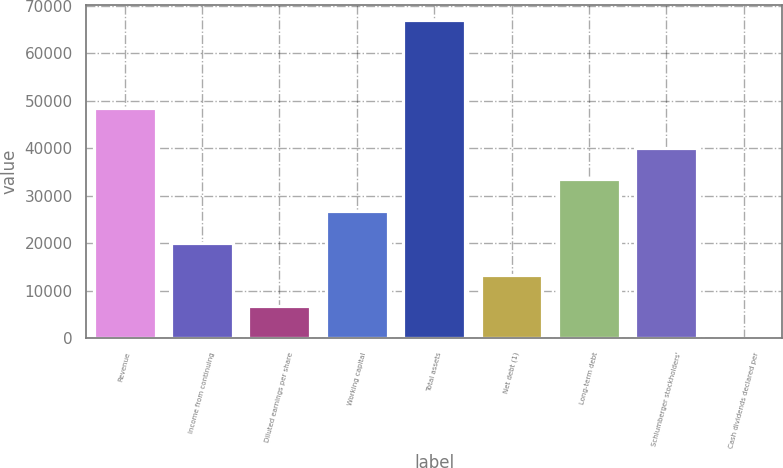Convert chart. <chart><loc_0><loc_0><loc_500><loc_500><bar_chart><fcel>Revenue<fcel>Income from continuing<fcel>Diluted earnings per share<fcel>Working capital<fcel>Total assets<fcel>Net debt (1)<fcel>Long-term debt<fcel>Schlumberger stockholders'<fcel>Cash dividends declared per<nl><fcel>48580<fcel>20072.3<fcel>6691.84<fcel>26762.6<fcel>66904<fcel>13382.1<fcel>33452.8<fcel>40143<fcel>1.6<nl></chart> 